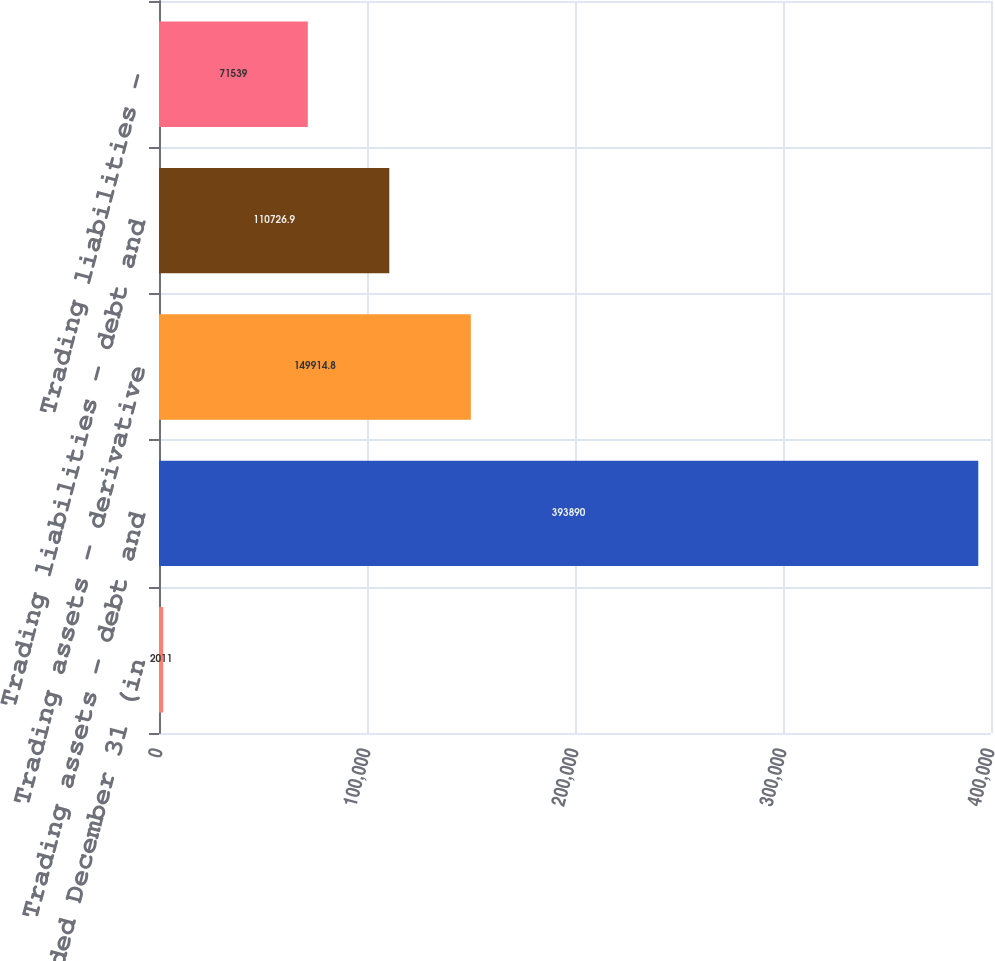<chart> <loc_0><loc_0><loc_500><loc_500><bar_chart><fcel>Year ended December 31 (in<fcel>Trading assets - debt and<fcel>Trading assets - derivative<fcel>Trading liabilities - debt and<fcel>Trading liabilities -<nl><fcel>2011<fcel>393890<fcel>149915<fcel>110727<fcel>71539<nl></chart> 